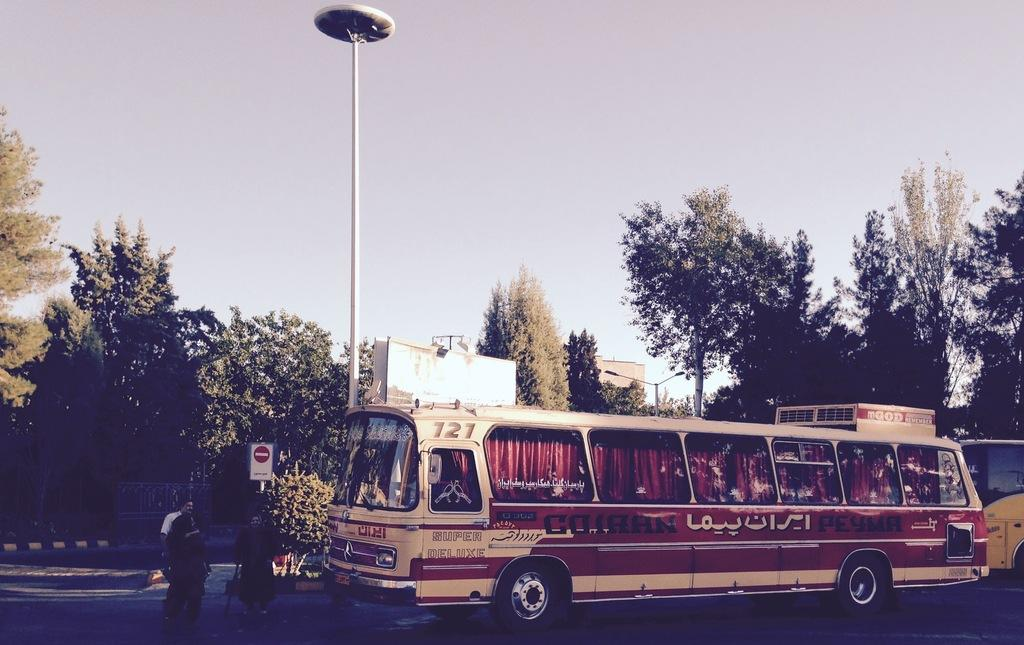<image>
Write a terse but informative summary of the picture. The 121 bus is parked by the curb near a yellow bus. 